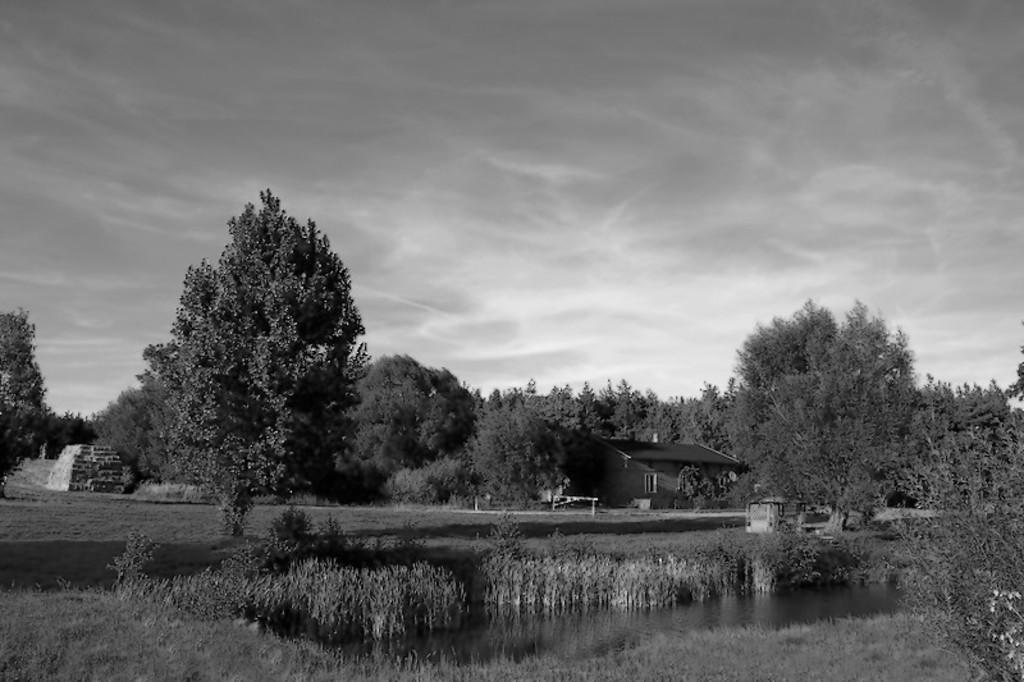What type of vegetation can be seen in the image? There are many trees, plants, and grass in the image. What is located at the bottom of the image? There is water at the bottom of the image. What structures can be seen in the background of the image? There is a shed and a building in the background of the image. What is visible at the top of the image? The sky is visible at the top of the image. What can be seen in the sky? Clouds are present in the sky. What letters are visible on the moon in the image? There is no moon present in the image, and therefore no letters can be seen on it. 